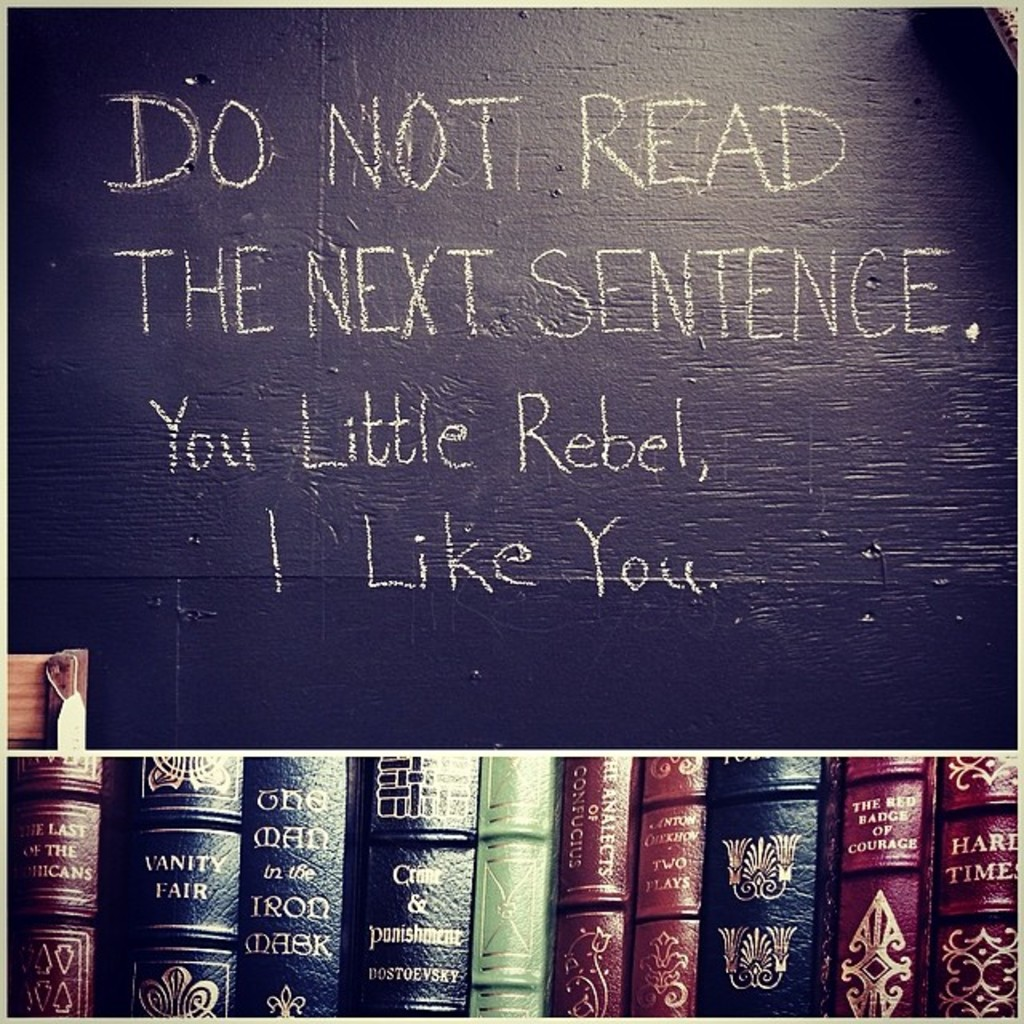Can you identify any themes or ideas common to the books shown below the message? The books displayed below the message include a selection of classic and contemporary literature, which reflect themes of adventure, societal critique, and human experiences. Titles like 'Vanity Fair' and 'The Count of Monte Cristo' suggest a fondness for intricate, character-driven narratives that explore themes of morality, justice, and human resilience. The presence of these books underlines the intellectual ambiance, hinting that the setting encourages reflective reading and contemplation of complex themes. 